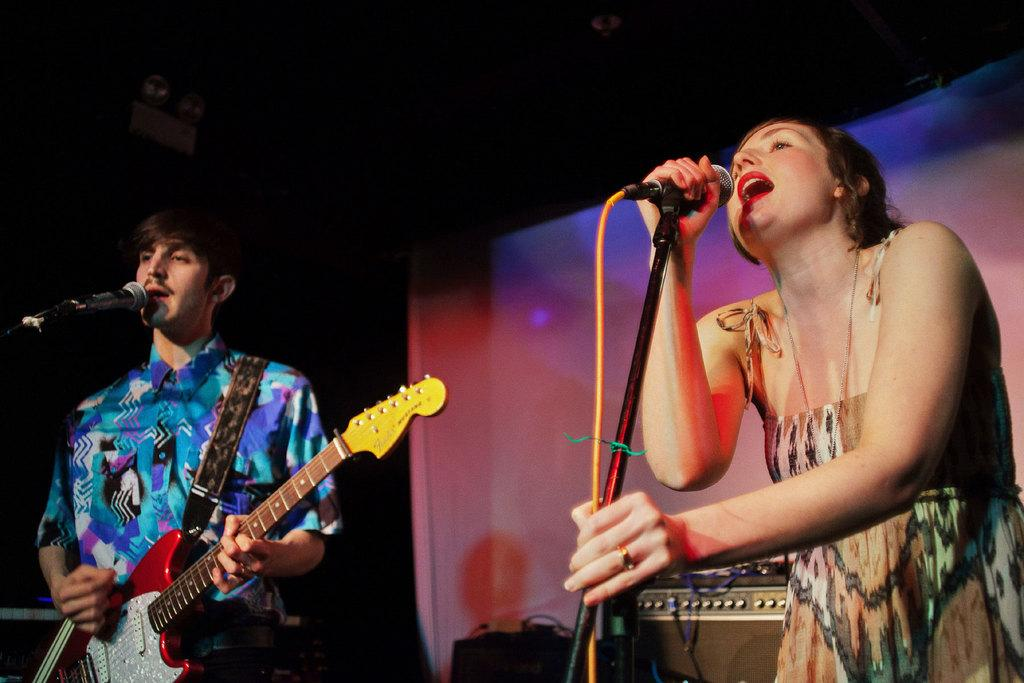What is the woman doing in the image? The woman is standing in front of a mic. What is the man doing in the image? The man is standing in front of a mic and holding a guitar. What can be seen in the background of the image? There is equipment visible in the background of the image. What type of beam is holding up the ceiling in the image? There is no beam visible in the image, as the focus is on the woman and the man with their respective microphones and guitar. 